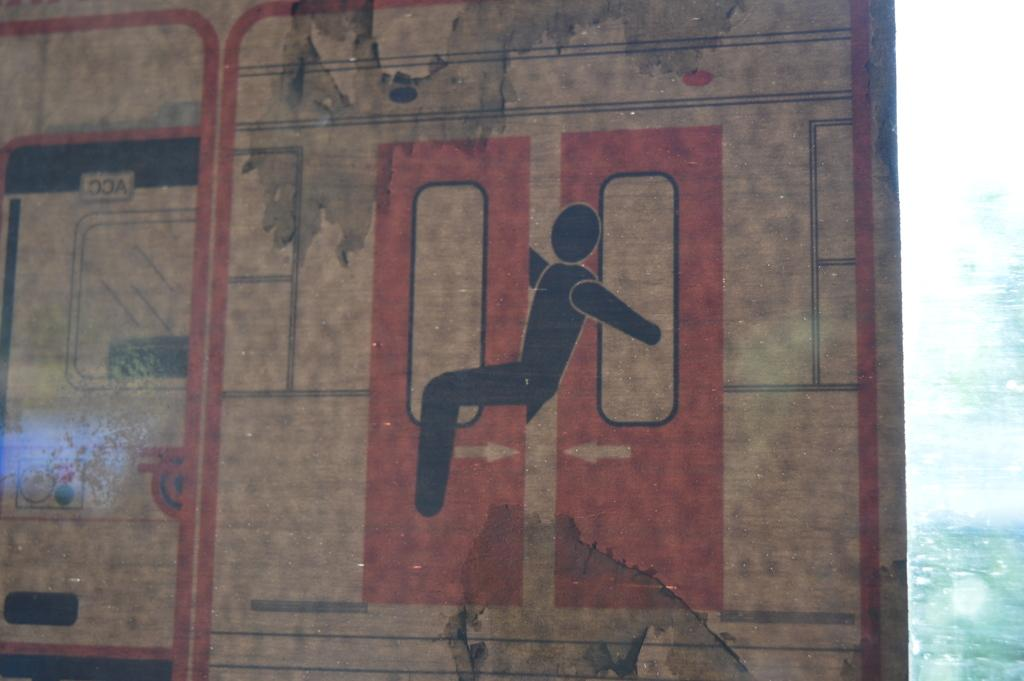What is the main object in the image? There is a sign board in the image. What colors are used for the sign board? The sign board is cream, red, and brown in color. Can you describe the background of the image? The background of the image is white and green. How many cows can be seen grazing in the background of the image? There are no cows present in the image; the background is white and green. What type of glass is used to make the sign board? The sign board is not made of glass; it is made of other materials, as indicated by its colors. 